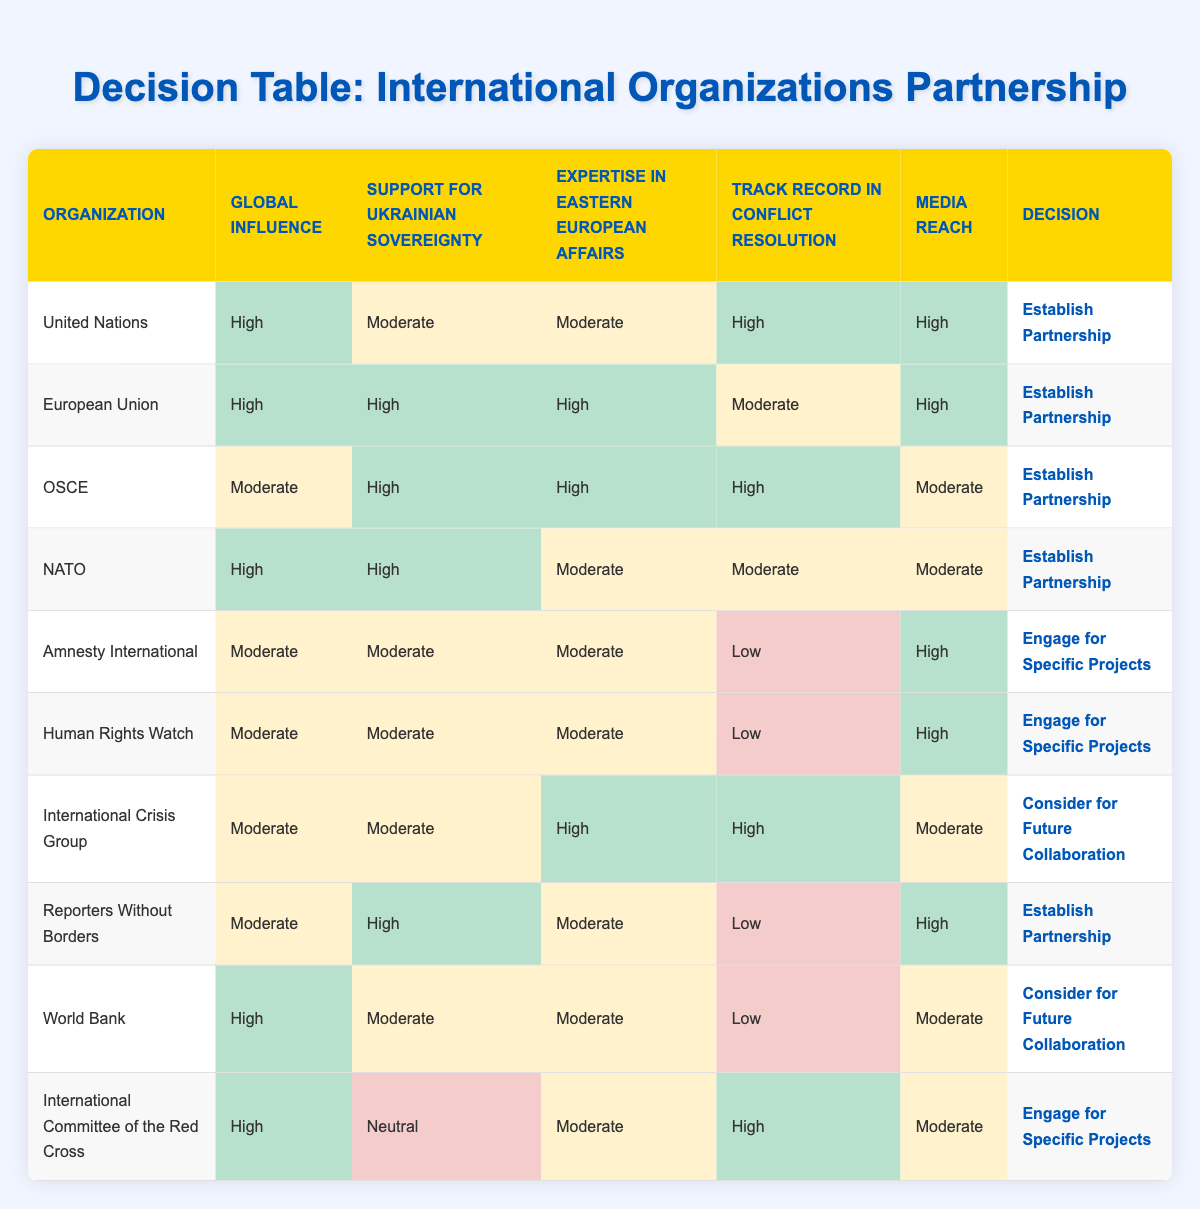What is the organization with the highest media reach? By looking at the media reach column, we can see that both the United Nations, European Union, Amnesty International, Human Rights Watch, and Reporters Without Borders have "High" media reach. Comparing these, the organization names which correspond with the highest media reach can include any of these five.
Answer: United Nations, European Union, Amnesty International, Human Rights Watch, Reporters Without Borders Which organizations are recommended to establish a partnership? The decision column shows that the United Nations, European Union, OSCE, NATO, and Reporters Without Borders are all recommended to "Establish Partnership."
Answer: United Nations, European Union, OSCE, NATO, Reporters Without Borders Is the International Crisis Group recommended to establish a partnership? The decision for the International Crisis Group is to "Consider for Future Collaboration," which indicates that it is not recommended to establish a partnership at this time.
Answer: No What is the average level of global influence for organizations listed? To calculate the average global influence, count the instances of High (5), Moderate (5), and Low (0). Convert these categorizations (High=3, Moderate=2, Low=1) into numerical values: (3*5 + 2*5 + 0*0) / 10 = (15 + 10) / 10 = 25 / 10 = 2.5 on a scale of 0 to 3, which falls in between Moderate and High influence.
Answer: Moderate to High Does the World Bank have a high track record in conflict resolution? The World Bank has a "Low" rating in the track record in conflict resolution column, indicating it does not qualify as having a high track record.
Answer: No What other organizations also scored "Moderate" in expertise in Eastern European affairs? By examining the expertise in Eastern European affairs column, we see organizations like the United Nations, Amnesty International, Human Rights Watch, International Crisis Group, World Bank, and International Committee of the Red Cross with a "Moderate" rating.
Answer: United Nations, Amnesty International, Human Rights Watch, International Crisis Group, World Bank, International Committee of the Red Cross Which organization is the only one that has a neutral stance on supporting Ukrainian sovereignty? The International Committee of the Red Cross has a "Neutral" stance regarding support for Ukrainian sovereignty, as indicated in the support for Ukrainian sovereignty column.
Answer: International Committee of the Red Cross Can we identify unique organizations that have high ratings in both global influence and media reach? By checking both global influence and media reach columns, we find the United Nations, European Union, and Reporters Without Borders all have "High" ratings in both categories.
Answer: United Nations, European Union, Reporters Without Borders How many organizations have a "Low" track record in conflict resolution? The organizations with a "Low" rating in the track record in conflict resolution column are Amnesty International, Human Rights Watch, and Reporters Without Borders. There are three organizations in total.
Answer: Three 